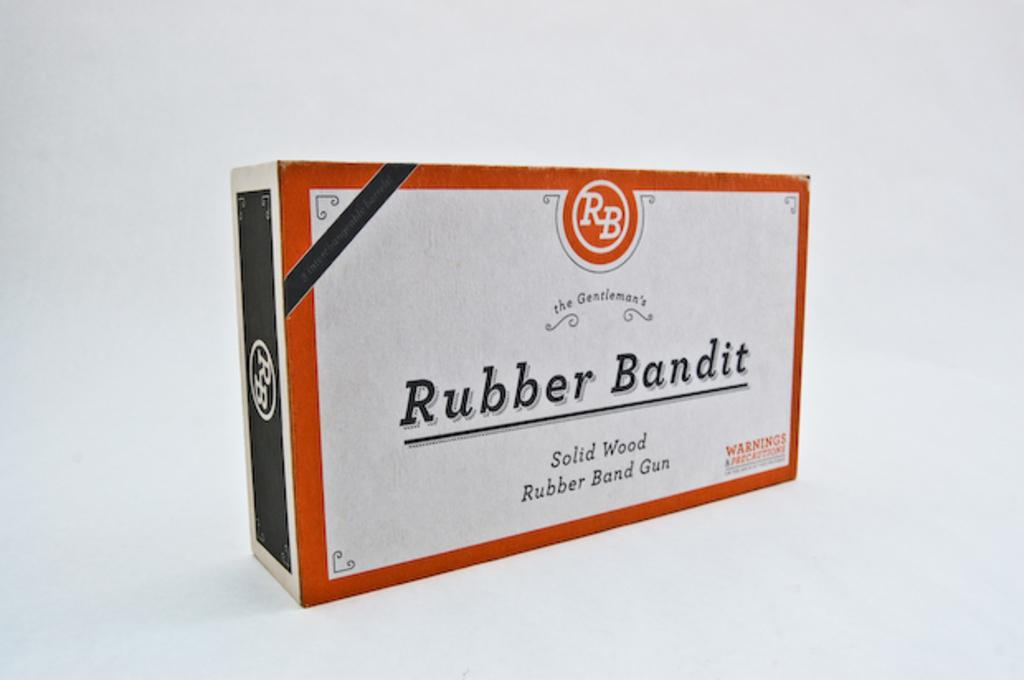Provide a one-sentence caption for the provided image. A box for a Rubber Bandit brand rubber band gun. 